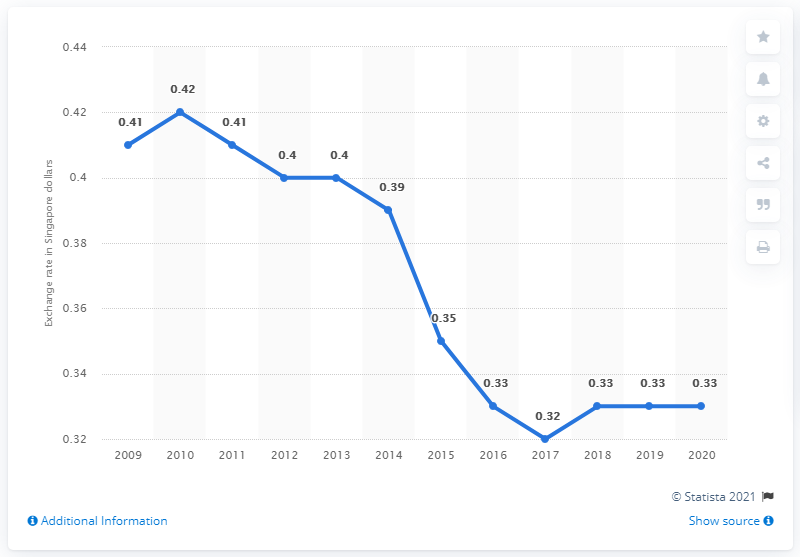Mention a couple of crucial points in this snapshot. In 2020, the average exchange rate from Singapore dollar to Malaysian ringgit was 0.33. The average exchange rate from Singapore dollar to Malaysian ringgit in 2020 was 0.33. 